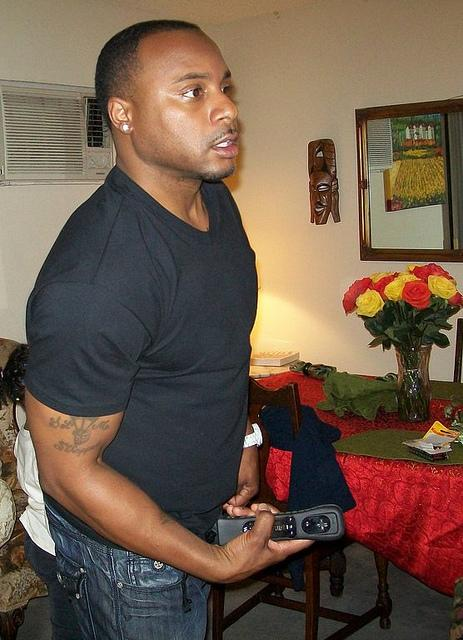The remote is meant to communicate with what?

Choices:
A) telephone
B) computer
C) television
D) video game television 